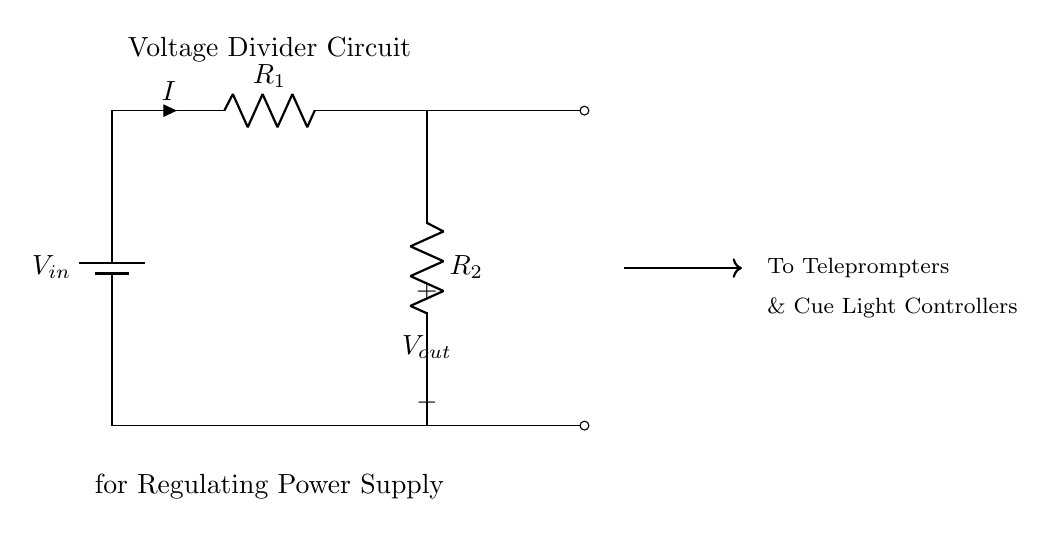What is the input voltage of this circuit? The input voltage, denoted as V in the circuit, is the voltage supplied to the circuit by the battery at the top. It is the potential difference across the terminals of the battery.
Answer: V in What are the two resistors in this circuit? The two resistors present in the circuit diagram are labeled as R1 and R2. They are components that resist the flow of electric current and are essential for creating the voltage divider effect.
Answer: R1 and R2 What is the output voltage measured across? The output voltage, labeled as V out in the circuit, is measured across R2, which is the lower resistor in the voltage divider configuration. This voltage is the result of the division of the input voltage based on the values of R1 and R2.
Answer: R2 What type of circuit is this? This is a voltage divider circuit, which is specifically designed to reduce the input voltage into a desired lower output voltage. It consists of resistors arranged in series.
Answer: Voltage divider How does the current flow in this circuit? The current flows from the battery through R1, then through R2, and finally returns to the battery. The direction of the current is indicated by the arrow showing the current’s flow direction, starting at the positive terminal of the battery and completing the circuit back to the negative terminal.
Answer: From battery through R1 to R2 What happens to the output voltage if R1 is much larger than R2? If R1 is much larger than R2, the output voltage V out will be significantly lower than the input voltage V in. This occurs because a larger proportion of the input voltage drops across R1, leading to a smaller voltage drop across R2.
Answer: V out will be low 